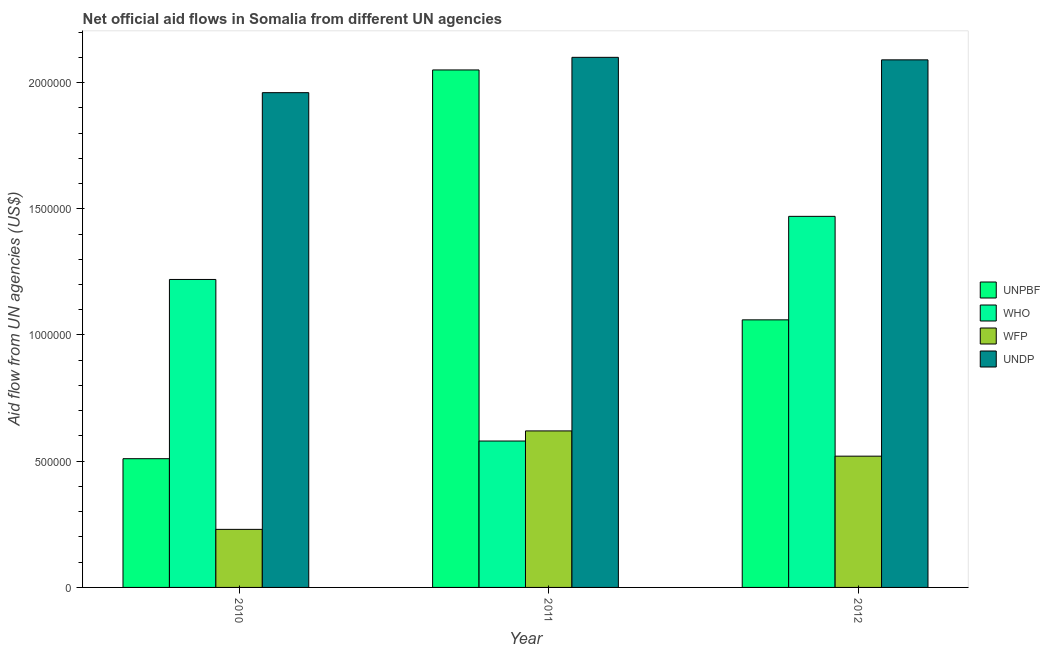Are the number of bars per tick equal to the number of legend labels?
Offer a very short reply. Yes. How many bars are there on the 3rd tick from the right?
Offer a very short reply. 4. In how many cases, is the number of bars for a given year not equal to the number of legend labels?
Give a very brief answer. 0. What is the amount of aid given by who in 2011?
Offer a terse response. 5.80e+05. Across all years, what is the maximum amount of aid given by unpbf?
Offer a very short reply. 2.05e+06. Across all years, what is the minimum amount of aid given by unpbf?
Your response must be concise. 5.10e+05. What is the total amount of aid given by wfp in the graph?
Give a very brief answer. 1.37e+06. What is the difference between the amount of aid given by who in 2010 and that in 2011?
Your answer should be very brief. 6.40e+05. What is the difference between the amount of aid given by wfp in 2010 and the amount of aid given by who in 2011?
Your answer should be compact. -3.90e+05. What is the average amount of aid given by unpbf per year?
Provide a short and direct response. 1.21e+06. In the year 2010, what is the difference between the amount of aid given by unpbf and amount of aid given by who?
Provide a succinct answer. 0. What is the ratio of the amount of aid given by unpbf in 2010 to that in 2012?
Provide a succinct answer. 0.48. Is the amount of aid given by who in 2010 less than that in 2012?
Keep it short and to the point. Yes. What is the difference between the highest and the lowest amount of aid given by wfp?
Ensure brevity in your answer.  3.90e+05. Is it the case that in every year, the sum of the amount of aid given by who and amount of aid given by wfp is greater than the sum of amount of aid given by undp and amount of aid given by unpbf?
Your answer should be compact. No. What does the 3rd bar from the left in 2012 represents?
Keep it short and to the point. WFP. What does the 1st bar from the right in 2012 represents?
Your answer should be very brief. UNDP. Is it the case that in every year, the sum of the amount of aid given by unpbf and amount of aid given by who is greater than the amount of aid given by wfp?
Give a very brief answer. Yes. How many years are there in the graph?
Ensure brevity in your answer.  3. Does the graph contain grids?
Make the answer very short. No. How many legend labels are there?
Ensure brevity in your answer.  4. What is the title of the graph?
Ensure brevity in your answer.  Net official aid flows in Somalia from different UN agencies. Does "Tertiary education" appear as one of the legend labels in the graph?
Your response must be concise. No. What is the label or title of the X-axis?
Keep it short and to the point. Year. What is the label or title of the Y-axis?
Offer a terse response. Aid flow from UN agencies (US$). What is the Aid flow from UN agencies (US$) in UNPBF in 2010?
Make the answer very short. 5.10e+05. What is the Aid flow from UN agencies (US$) in WHO in 2010?
Give a very brief answer. 1.22e+06. What is the Aid flow from UN agencies (US$) in WFP in 2010?
Your response must be concise. 2.30e+05. What is the Aid flow from UN agencies (US$) in UNDP in 2010?
Ensure brevity in your answer.  1.96e+06. What is the Aid flow from UN agencies (US$) of UNPBF in 2011?
Make the answer very short. 2.05e+06. What is the Aid flow from UN agencies (US$) in WHO in 2011?
Your answer should be compact. 5.80e+05. What is the Aid flow from UN agencies (US$) of WFP in 2011?
Make the answer very short. 6.20e+05. What is the Aid flow from UN agencies (US$) in UNDP in 2011?
Provide a short and direct response. 2.10e+06. What is the Aid flow from UN agencies (US$) of UNPBF in 2012?
Give a very brief answer. 1.06e+06. What is the Aid flow from UN agencies (US$) in WHO in 2012?
Make the answer very short. 1.47e+06. What is the Aid flow from UN agencies (US$) in WFP in 2012?
Offer a terse response. 5.20e+05. What is the Aid flow from UN agencies (US$) of UNDP in 2012?
Ensure brevity in your answer.  2.09e+06. Across all years, what is the maximum Aid flow from UN agencies (US$) in UNPBF?
Your answer should be very brief. 2.05e+06. Across all years, what is the maximum Aid flow from UN agencies (US$) in WHO?
Offer a terse response. 1.47e+06. Across all years, what is the maximum Aid flow from UN agencies (US$) of WFP?
Provide a short and direct response. 6.20e+05. Across all years, what is the maximum Aid flow from UN agencies (US$) in UNDP?
Your answer should be very brief. 2.10e+06. Across all years, what is the minimum Aid flow from UN agencies (US$) of UNPBF?
Offer a terse response. 5.10e+05. Across all years, what is the minimum Aid flow from UN agencies (US$) of WHO?
Offer a very short reply. 5.80e+05. Across all years, what is the minimum Aid flow from UN agencies (US$) in UNDP?
Your answer should be compact. 1.96e+06. What is the total Aid flow from UN agencies (US$) of UNPBF in the graph?
Offer a terse response. 3.62e+06. What is the total Aid flow from UN agencies (US$) of WHO in the graph?
Your answer should be compact. 3.27e+06. What is the total Aid flow from UN agencies (US$) of WFP in the graph?
Provide a succinct answer. 1.37e+06. What is the total Aid flow from UN agencies (US$) of UNDP in the graph?
Your response must be concise. 6.15e+06. What is the difference between the Aid flow from UN agencies (US$) of UNPBF in 2010 and that in 2011?
Make the answer very short. -1.54e+06. What is the difference between the Aid flow from UN agencies (US$) in WHO in 2010 and that in 2011?
Provide a short and direct response. 6.40e+05. What is the difference between the Aid flow from UN agencies (US$) of WFP in 2010 and that in 2011?
Your answer should be very brief. -3.90e+05. What is the difference between the Aid flow from UN agencies (US$) in UNDP in 2010 and that in 2011?
Keep it short and to the point. -1.40e+05. What is the difference between the Aid flow from UN agencies (US$) of UNPBF in 2010 and that in 2012?
Ensure brevity in your answer.  -5.50e+05. What is the difference between the Aid flow from UN agencies (US$) in WFP in 2010 and that in 2012?
Ensure brevity in your answer.  -2.90e+05. What is the difference between the Aid flow from UN agencies (US$) of UNDP in 2010 and that in 2012?
Your answer should be very brief. -1.30e+05. What is the difference between the Aid flow from UN agencies (US$) of UNPBF in 2011 and that in 2012?
Give a very brief answer. 9.90e+05. What is the difference between the Aid flow from UN agencies (US$) of WHO in 2011 and that in 2012?
Provide a succinct answer. -8.90e+05. What is the difference between the Aid flow from UN agencies (US$) in WFP in 2011 and that in 2012?
Offer a very short reply. 1.00e+05. What is the difference between the Aid flow from UN agencies (US$) in UNPBF in 2010 and the Aid flow from UN agencies (US$) in WHO in 2011?
Give a very brief answer. -7.00e+04. What is the difference between the Aid flow from UN agencies (US$) in UNPBF in 2010 and the Aid flow from UN agencies (US$) in WFP in 2011?
Offer a very short reply. -1.10e+05. What is the difference between the Aid flow from UN agencies (US$) in UNPBF in 2010 and the Aid flow from UN agencies (US$) in UNDP in 2011?
Offer a terse response. -1.59e+06. What is the difference between the Aid flow from UN agencies (US$) in WHO in 2010 and the Aid flow from UN agencies (US$) in UNDP in 2011?
Provide a succinct answer. -8.80e+05. What is the difference between the Aid flow from UN agencies (US$) in WFP in 2010 and the Aid flow from UN agencies (US$) in UNDP in 2011?
Offer a very short reply. -1.87e+06. What is the difference between the Aid flow from UN agencies (US$) of UNPBF in 2010 and the Aid flow from UN agencies (US$) of WHO in 2012?
Your answer should be compact. -9.60e+05. What is the difference between the Aid flow from UN agencies (US$) in UNPBF in 2010 and the Aid flow from UN agencies (US$) in WFP in 2012?
Offer a very short reply. -10000. What is the difference between the Aid flow from UN agencies (US$) of UNPBF in 2010 and the Aid flow from UN agencies (US$) of UNDP in 2012?
Offer a terse response. -1.58e+06. What is the difference between the Aid flow from UN agencies (US$) in WHO in 2010 and the Aid flow from UN agencies (US$) in UNDP in 2012?
Make the answer very short. -8.70e+05. What is the difference between the Aid flow from UN agencies (US$) of WFP in 2010 and the Aid flow from UN agencies (US$) of UNDP in 2012?
Ensure brevity in your answer.  -1.86e+06. What is the difference between the Aid flow from UN agencies (US$) of UNPBF in 2011 and the Aid flow from UN agencies (US$) of WHO in 2012?
Offer a very short reply. 5.80e+05. What is the difference between the Aid flow from UN agencies (US$) of UNPBF in 2011 and the Aid flow from UN agencies (US$) of WFP in 2012?
Offer a terse response. 1.53e+06. What is the difference between the Aid flow from UN agencies (US$) in UNPBF in 2011 and the Aid flow from UN agencies (US$) in UNDP in 2012?
Offer a very short reply. -4.00e+04. What is the difference between the Aid flow from UN agencies (US$) in WHO in 2011 and the Aid flow from UN agencies (US$) in UNDP in 2012?
Your answer should be compact. -1.51e+06. What is the difference between the Aid flow from UN agencies (US$) in WFP in 2011 and the Aid flow from UN agencies (US$) in UNDP in 2012?
Your answer should be very brief. -1.47e+06. What is the average Aid flow from UN agencies (US$) of UNPBF per year?
Offer a very short reply. 1.21e+06. What is the average Aid flow from UN agencies (US$) of WHO per year?
Your response must be concise. 1.09e+06. What is the average Aid flow from UN agencies (US$) in WFP per year?
Make the answer very short. 4.57e+05. What is the average Aid flow from UN agencies (US$) of UNDP per year?
Provide a short and direct response. 2.05e+06. In the year 2010, what is the difference between the Aid flow from UN agencies (US$) of UNPBF and Aid flow from UN agencies (US$) of WHO?
Make the answer very short. -7.10e+05. In the year 2010, what is the difference between the Aid flow from UN agencies (US$) in UNPBF and Aid flow from UN agencies (US$) in WFP?
Give a very brief answer. 2.80e+05. In the year 2010, what is the difference between the Aid flow from UN agencies (US$) in UNPBF and Aid flow from UN agencies (US$) in UNDP?
Provide a succinct answer. -1.45e+06. In the year 2010, what is the difference between the Aid flow from UN agencies (US$) of WHO and Aid flow from UN agencies (US$) of WFP?
Your answer should be compact. 9.90e+05. In the year 2010, what is the difference between the Aid flow from UN agencies (US$) in WHO and Aid flow from UN agencies (US$) in UNDP?
Provide a succinct answer. -7.40e+05. In the year 2010, what is the difference between the Aid flow from UN agencies (US$) in WFP and Aid flow from UN agencies (US$) in UNDP?
Your answer should be compact. -1.73e+06. In the year 2011, what is the difference between the Aid flow from UN agencies (US$) in UNPBF and Aid flow from UN agencies (US$) in WHO?
Keep it short and to the point. 1.47e+06. In the year 2011, what is the difference between the Aid flow from UN agencies (US$) of UNPBF and Aid flow from UN agencies (US$) of WFP?
Keep it short and to the point. 1.43e+06. In the year 2011, what is the difference between the Aid flow from UN agencies (US$) of WHO and Aid flow from UN agencies (US$) of WFP?
Ensure brevity in your answer.  -4.00e+04. In the year 2011, what is the difference between the Aid flow from UN agencies (US$) of WHO and Aid flow from UN agencies (US$) of UNDP?
Your answer should be very brief. -1.52e+06. In the year 2011, what is the difference between the Aid flow from UN agencies (US$) of WFP and Aid flow from UN agencies (US$) of UNDP?
Your response must be concise. -1.48e+06. In the year 2012, what is the difference between the Aid flow from UN agencies (US$) of UNPBF and Aid flow from UN agencies (US$) of WHO?
Make the answer very short. -4.10e+05. In the year 2012, what is the difference between the Aid flow from UN agencies (US$) of UNPBF and Aid flow from UN agencies (US$) of WFP?
Keep it short and to the point. 5.40e+05. In the year 2012, what is the difference between the Aid flow from UN agencies (US$) in UNPBF and Aid flow from UN agencies (US$) in UNDP?
Your answer should be compact. -1.03e+06. In the year 2012, what is the difference between the Aid flow from UN agencies (US$) in WHO and Aid flow from UN agencies (US$) in WFP?
Ensure brevity in your answer.  9.50e+05. In the year 2012, what is the difference between the Aid flow from UN agencies (US$) of WHO and Aid flow from UN agencies (US$) of UNDP?
Give a very brief answer. -6.20e+05. In the year 2012, what is the difference between the Aid flow from UN agencies (US$) in WFP and Aid flow from UN agencies (US$) in UNDP?
Offer a very short reply. -1.57e+06. What is the ratio of the Aid flow from UN agencies (US$) of UNPBF in 2010 to that in 2011?
Give a very brief answer. 0.25. What is the ratio of the Aid flow from UN agencies (US$) in WHO in 2010 to that in 2011?
Provide a short and direct response. 2.1. What is the ratio of the Aid flow from UN agencies (US$) of WFP in 2010 to that in 2011?
Provide a succinct answer. 0.37. What is the ratio of the Aid flow from UN agencies (US$) in UNDP in 2010 to that in 2011?
Your response must be concise. 0.93. What is the ratio of the Aid flow from UN agencies (US$) of UNPBF in 2010 to that in 2012?
Offer a very short reply. 0.48. What is the ratio of the Aid flow from UN agencies (US$) in WHO in 2010 to that in 2012?
Offer a very short reply. 0.83. What is the ratio of the Aid flow from UN agencies (US$) of WFP in 2010 to that in 2012?
Your response must be concise. 0.44. What is the ratio of the Aid flow from UN agencies (US$) of UNDP in 2010 to that in 2012?
Your response must be concise. 0.94. What is the ratio of the Aid flow from UN agencies (US$) in UNPBF in 2011 to that in 2012?
Ensure brevity in your answer.  1.93. What is the ratio of the Aid flow from UN agencies (US$) of WHO in 2011 to that in 2012?
Offer a very short reply. 0.39. What is the ratio of the Aid flow from UN agencies (US$) of WFP in 2011 to that in 2012?
Ensure brevity in your answer.  1.19. What is the ratio of the Aid flow from UN agencies (US$) of UNDP in 2011 to that in 2012?
Your answer should be very brief. 1. What is the difference between the highest and the second highest Aid flow from UN agencies (US$) in UNPBF?
Give a very brief answer. 9.90e+05. What is the difference between the highest and the second highest Aid flow from UN agencies (US$) in WHO?
Make the answer very short. 2.50e+05. What is the difference between the highest and the second highest Aid flow from UN agencies (US$) in WFP?
Your answer should be compact. 1.00e+05. What is the difference between the highest and the lowest Aid flow from UN agencies (US$) in UNPBF?
Keep it short and to the point. 1.54e+06. What is the difference between the highest and the lowest Aid flow from UN agencies (US$) of WHO?
Your answer should be very brief. 8.90e+05. What is the difference between the highest and the lowest Aid flow from UN agencies (US$) of WFP?
Provide a short and direct response. 3.90e+05. What is the difference between the highest and the lowest Aid flow from UN agencies (US$) in UNDP?
Offer a terse response. 1.40e+05. 